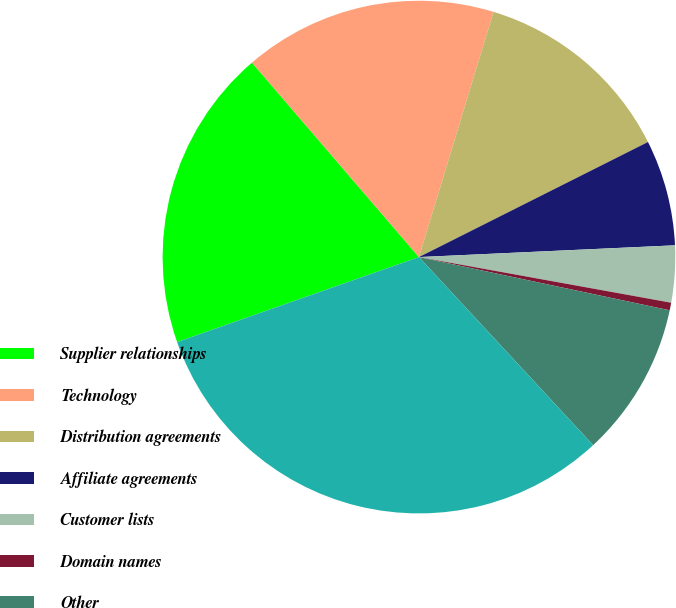<chart> <loc_0><loc_0><loc_500><loc_500><pie_chart><fcel>Supplier relationships<fcel>Technology<fcel>Distribution agreements<fcel>Affiliate agreements<fcel>Customer lists<fcel>Domain names<fcel>Other<fcel>Total<nl><fcel>19.09%<fcel>15.99%<fcel>12.89%<fcel>6.68%<fcel>3.58%<fcel>0.48%<fcel>9.78%<fcel>31.51%<nl></chart> 